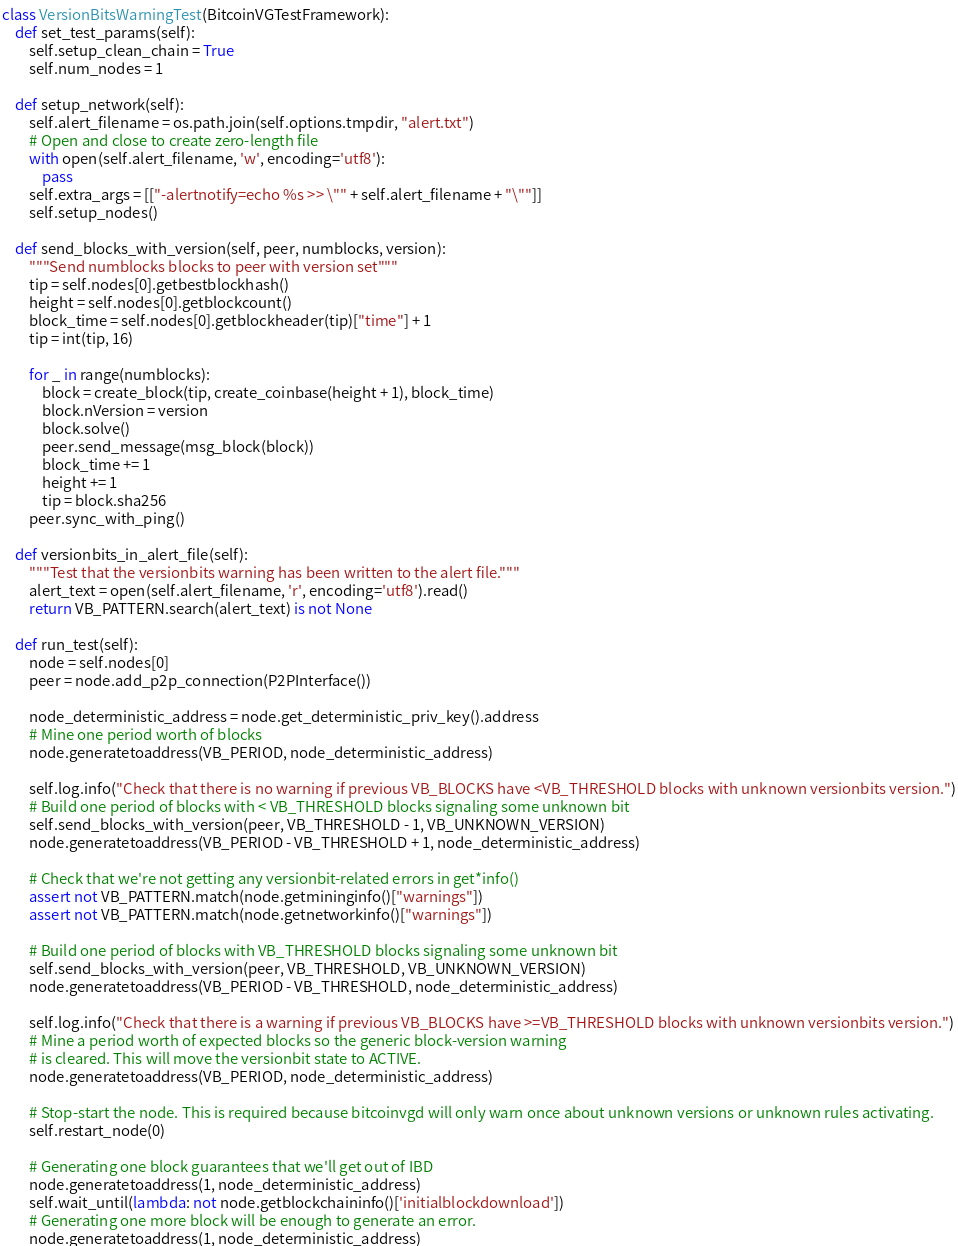<code> <loc_0><loc_0><loc_500><loc_500><_Python_>
class VersionBitsWarningTest(BitcoinVGTestFramework):
    def set_test_params(self):
        self.setup_clean_chain = True
        self.num_nodes = 1

    def setup_network(self):
        self.alert_filename = os.path.join(self.options.tmpdir, "alert.txt")
        # Open and close to create zero-length file
        with open(self.alert_filename, 'w', encoding='utf8'):
            pass
        self.extra_args = [["-alertnotify=echo %s >> \"" + self.alert_filename + "\""]]
        self.setup_nodes()

    def send_blocks_with_version(self, peer, numblocks, version):
        """Send numblocks blocks to peer with version set"""
        tip = self.nodes[0].getbestblockhash()
        height = self.nodes[0].getblockcount()
        block_time = self.nodes[0].getblockheader(tip)["time"] + 1
        tip = int(tip, 16)

        for _ in range(numblocks):
            block = create_block(tip, create_coinbase(height + 1), block_time)
            block.nVersion = version
            block.solve()
            peer.send_message(msg_block(block))
            block_time += 1
            height += 1
            tip = block.sha256
        peer.sync_with_ping()

    def versionbits_in_alert_file(self):
        """Test that the versionbits warning has been written to the alert file."""
        alert_text = open(self.alert_filename, 'r', encoding='utf8').read()
        return VB_PATTERN.search(alert_text) is not None

    def run_test(self):
        node = self.nodes[0]
        peer = node.add_p2p_connection(P2PInterface())

        node_deterministic_address = node.get_deterministic_priv_key().address
        # Mine one period worth of blocks
        node.generatetoaddress(VB_PERIOD, node_deterministic_address)

        self.log.info("Check that there is no warning if previous VB_BLOCKS have <VB_THRESHOLD blocks with unknown versionbits version.")
        # Build one period of blocks with < VB_THRESHOLD blocks signaling some unknown bit
        self.send_blocks_with_version(peer, VB_THRESHOLD - 1, VB_UNKNOWN_VERSION)
        node.generatetoaddress(VB_PERIOD - VB_THRESHOLD + 1, node_deterministic_address)

        # Check that we're not getting any versionbit-related errors in get*info()
        assert not VB_PATTERN.match(node.getmininginfo()["warnings"])
        assert not VB_PATTERN.match(node.getnetworkinfo()["warnings"])

        # Build one period of blocks with VB_THRESHOLD blocks signaling some unknown bit
        self.send_blocks_with_version(peer, VB_THRESHOLD, VB_UNKNOWN_VERSION)
        node.generatetoaddress(VB_PERIOD - VB_THRESHOLD, node_deterministic_address)

        self.log.info("Check that there is a warning if previous VB_BLOCKS have >=VB_THRESHOLD blocks with unknown versionbits version.")
        # Mine a period worth of expected blocks so the generic block-version warning
        # is cleared. This will move the versionbit state to ACTIVE.
        node.generatetoaddress(VB_PERIOD, node_deterministic_address)

        # Stop-start the node. This is required because bitcoinvgd will only warn once about unknown versions or unknown rules activating.
        self.restart_node(0)

        # Generating one block guarantees that we'll get out of IBD
        node.generatetoaddress(1, node_deterministic_address)
        self.wait_until(lambda: not node.getblockchaininfo()['initialblockdownload'])
        # Generating one more block will be enough to generate an error.
        node.generatetoaddress(1, node_deterministic_address)</code> 